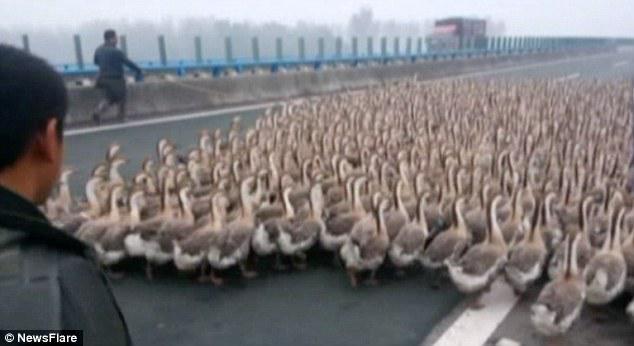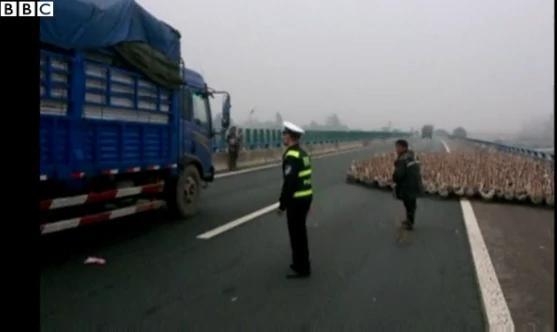The first image is the image on the left, the second image is the image on the right. Examine the images to the left and right. Is the description "There is an officer with yellow marked clothing in the street in one of the images." accurate? Answer yes or no. Yes. The first image is the image on the left, the second image is the image on the right. Evaluate the accuracy of this statement regarding the images: "There are some police involved, where the geese are blocking the street.". Is it true? Answer yes or no. Yes. 